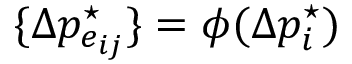Convert formula to latex. <formula><loc_0><loc_0><loc_500><loc_500>\{ \Delta p _ { e _ { i j } } ^ { ^ { * } } \} = \phi ( \Delta p _ { i } ^ { ^ { * } } )</formula> 